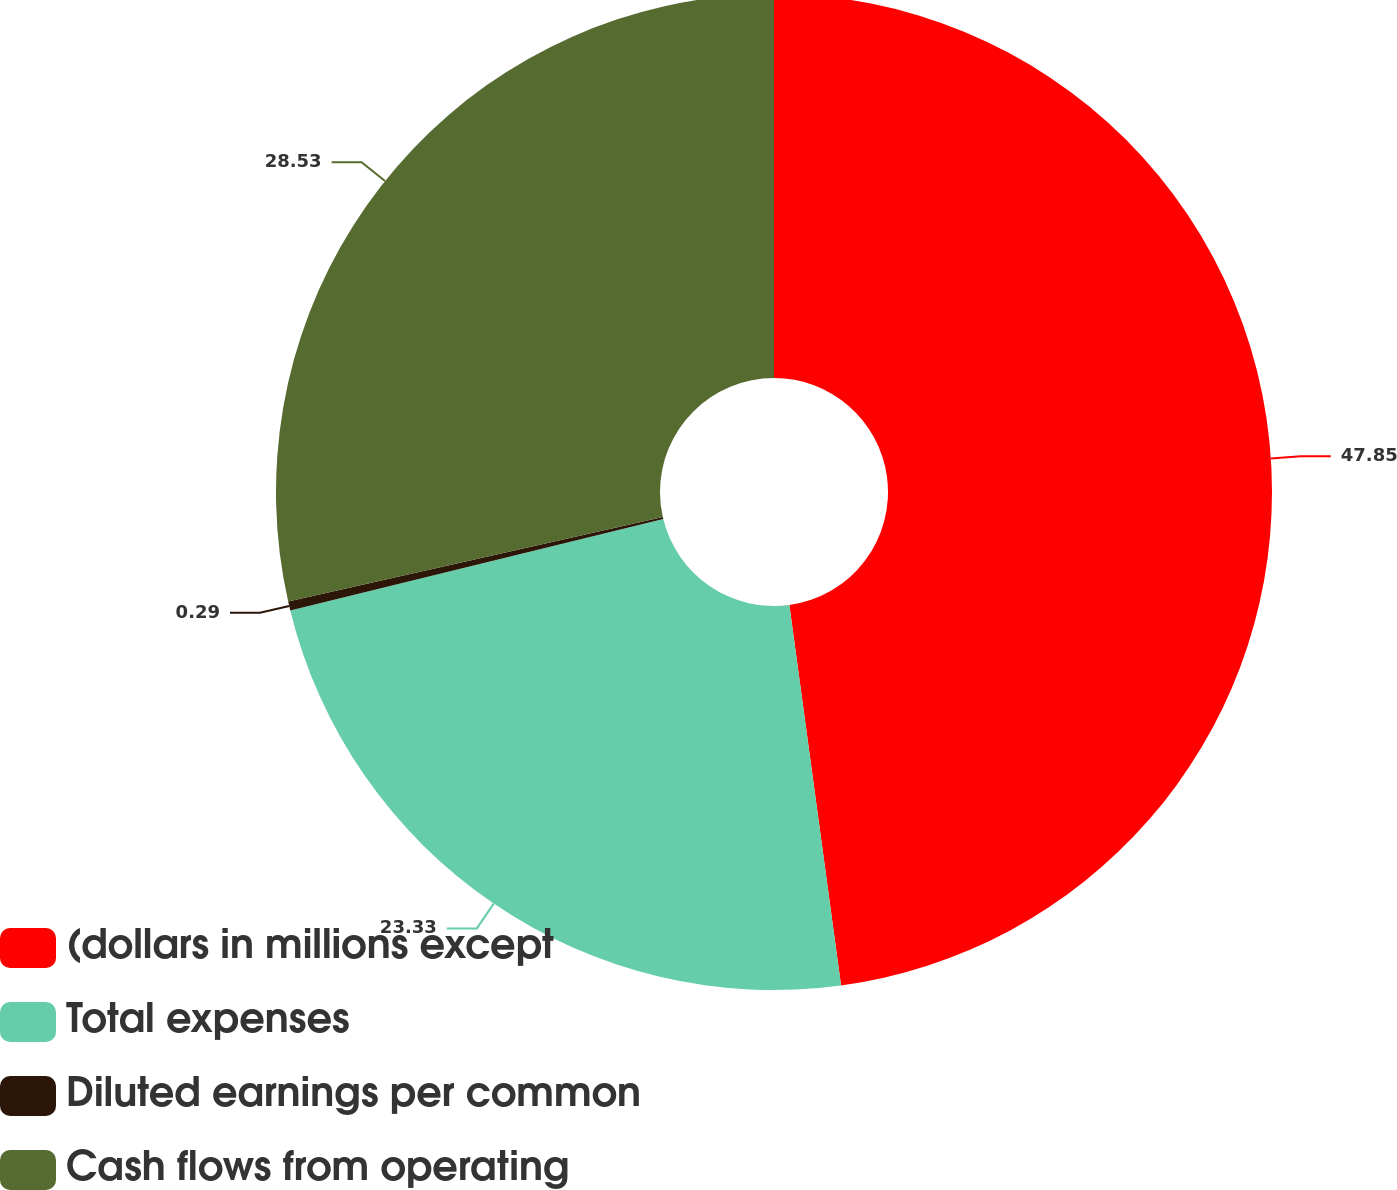Convert chart. <chart><loc_0><loc_0><loc_500><loc_500><pie_chart><fcel>(dollars in millions except<fcel>Total expenses<fcel>Diluted earnings per common<fcel>Cash flows from operating<nl><fcel>47.85%<fcel>23.33%<fcel>0.29%<fcel>28.53%<nl></chart> 